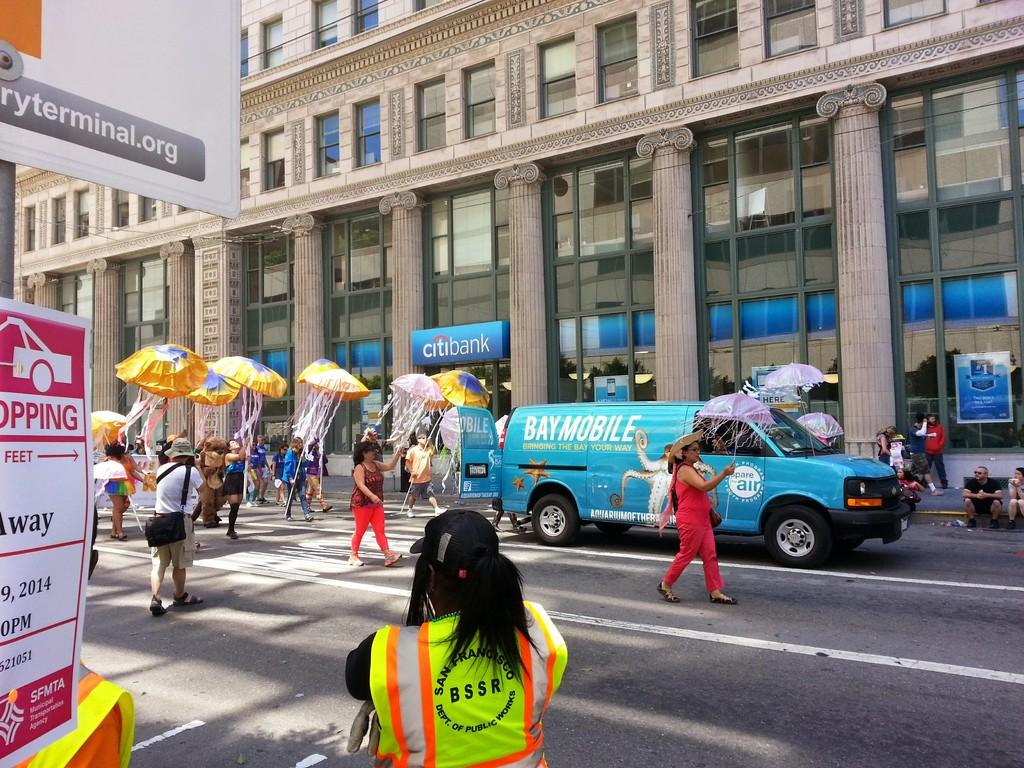<image>
Describe the image concisely. The building in the background behind the blue van is Citibank. 